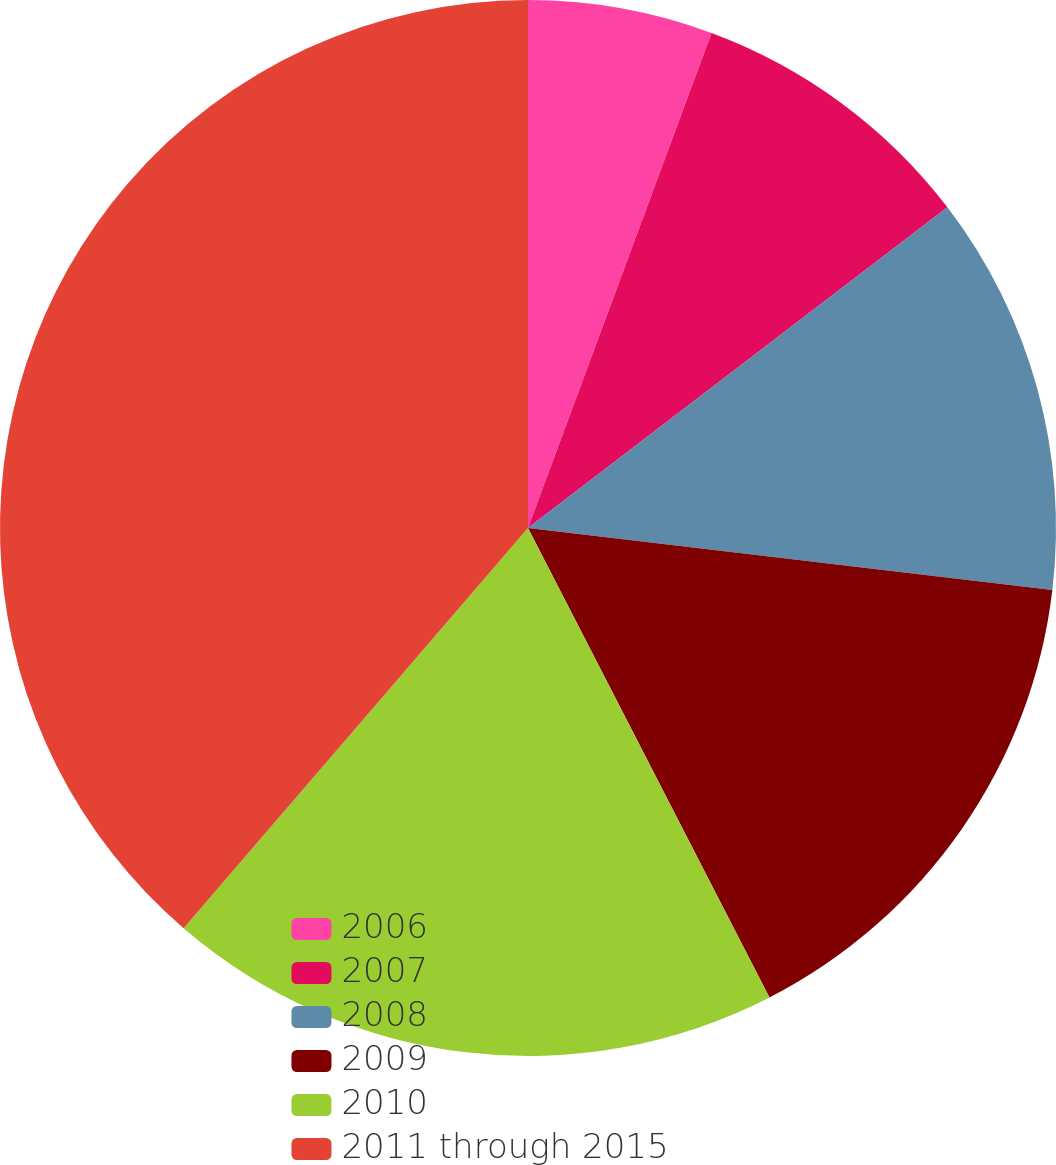Convert chart to OTSL. <chart><loc_0><loc_0><loc_500><loc_500><pie_chart><fcel>2006<fcel>2007<fcel>2008<fcel>2009<fcel>2010<fcel>2011 through 2015<nl><fcel>5.65%<fcel>8.96%<fcel>12.26%<fcel>15.57%<fcel>18.87%<fcel>38.69%<nl></chart> 